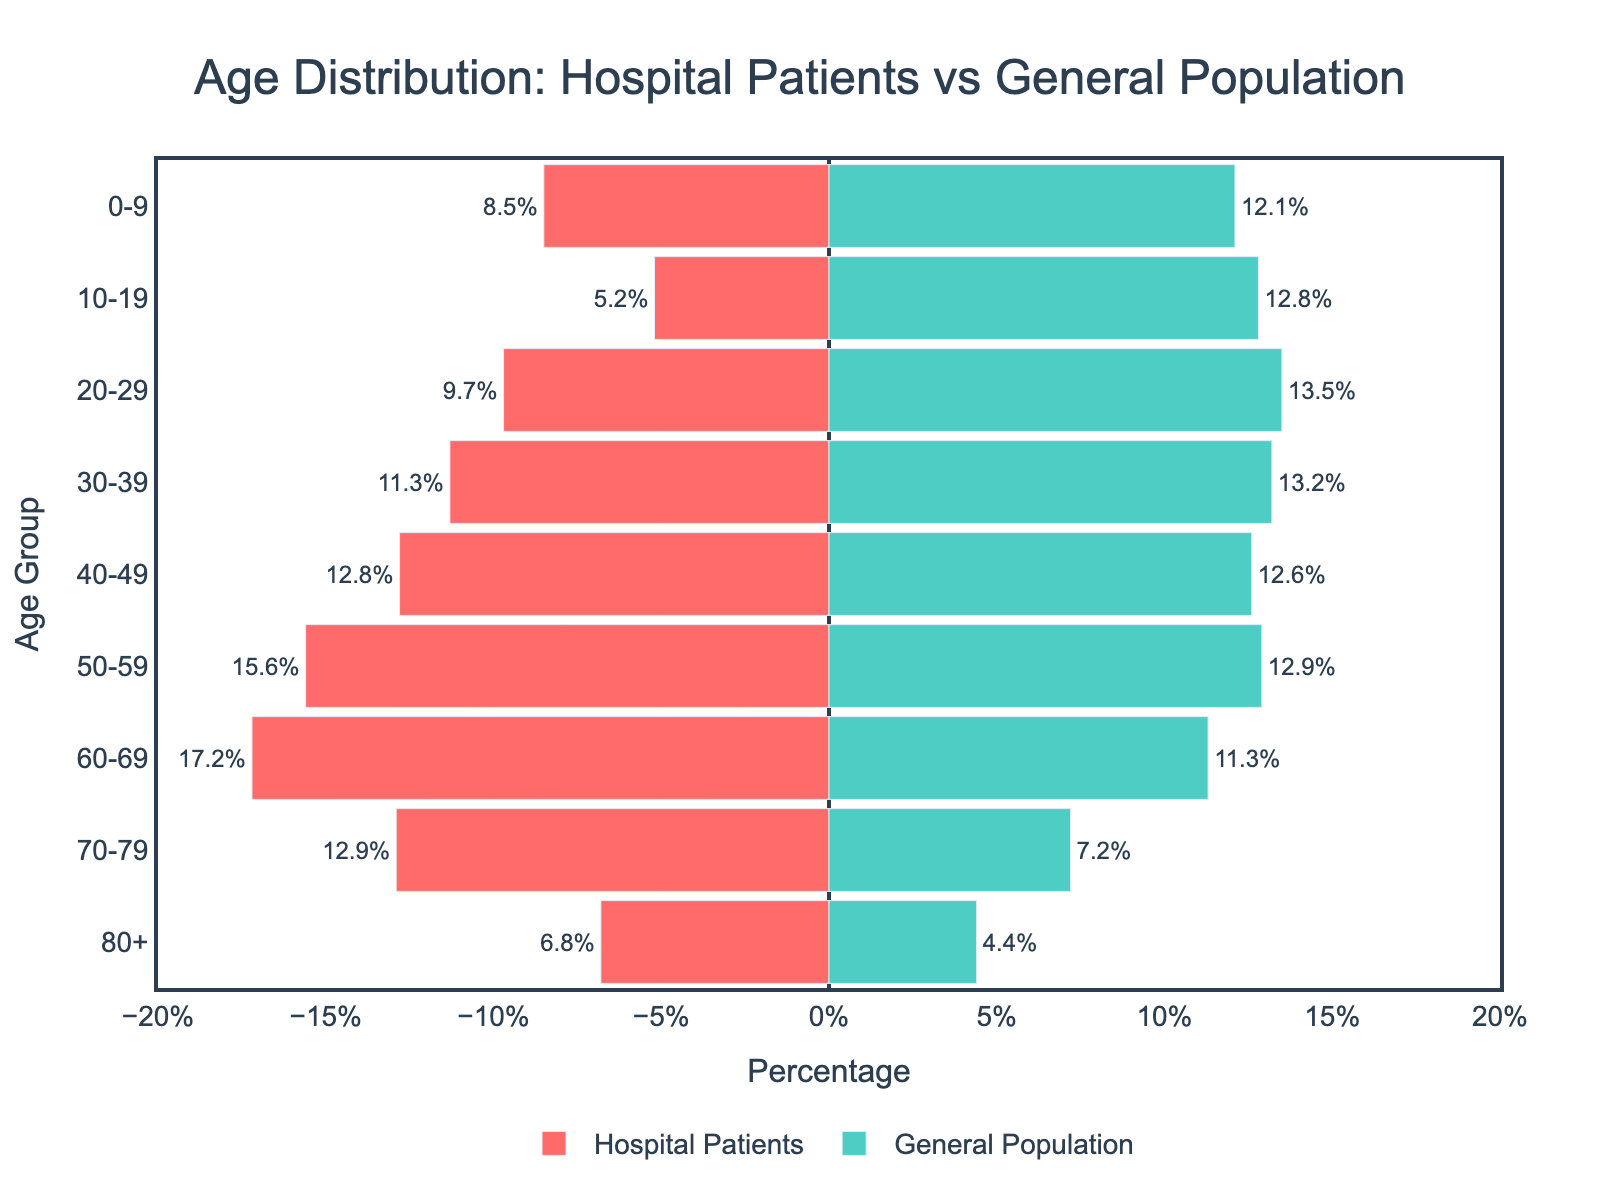What is the title of the plot? The title of the plot is prominently displayed at the top of the figure. It reads: "Age Distribution: Hospital Patients vs General Population."
Answer: Age Distribution: Hospital Patients vs General Population What color represents the Hospital Patients in the plot? The bars representing Hospital Patients are colored in red. This can be observed by looking at the bar section labeled "Hospital Patients" and its corresponding color.
Answer: Red Which age group has the highest percentage of Hospital Patients? The figure shows percentages for each age group. The age group "60-69" has the highest value on the Hospital Patients side, which is 17.2%.
Answer: 60-69 Which age group has the lowest percentage for the General Population? Looking at the General Population side's bars, the age group "80+" has the smallest percentage, which is 4.4%.
Answer: 80+ How does the percentage of Hospital Patients aged 70-79 compare to that of the General Population in the same age group? For the age group "70-79", the Hospital Patients percentage is 12.9%, while the General Population percentage is 7.2%. By comparing these values, we see that the percentage for Hospital Patients is higher.
Answer: Higher What is the combined (total) percentage of Hospital Patients for the 50-59 and 60-69 age groups? Adding the percentages for the "50-59" and "60-69" age groups for Hospital Patients: 15.6% + 17.2% = 32.8%.
Answer: 32.8% How does the sum of the percentages for age groups 0-9 and 10-19 for Hospital Patients compare to the sum for the same age groups in the General Population? For Hospital Patients, the sum for "0-9" and "10-19" is 8.5% + 5.2% = 13.7%. For the General Population, the sum for these age groups is 12.1% + 12.8% = 24.9%. By comparing 13.7% and 24.9%, we see that the sum for Hospital Patients is lower.
Answer: Lower Which age group shows the most significant difference between Hospital Patients and General Population? By examining the differences between Hospital Patients and General Population percentages for each age group, the age group "60-69" shows the largest difference. Specifically, Hospital Patients (17.2%) minus General Population (11.3%) equals a difference of 5.9 percentage points.
Answer: 60-69 What is the total percentage of the General Population for the age groups 30-49? Adding the percentages of the General Population for the age groups "30-39" (13.2%) and "40-49" (12.6%) gives: 13.2% + 12.6% = 25.8%.
Answer: 25.8% What age group in the General Population closely matches the percentage of Hospital Patients in the 40-49 age group? The percentage of Hospital Patients in the "40-49" age group is 12.8%. The closest matching percentage in the General Population is also in age group "40-49", which is 12.6%.
Answer: 40-49 